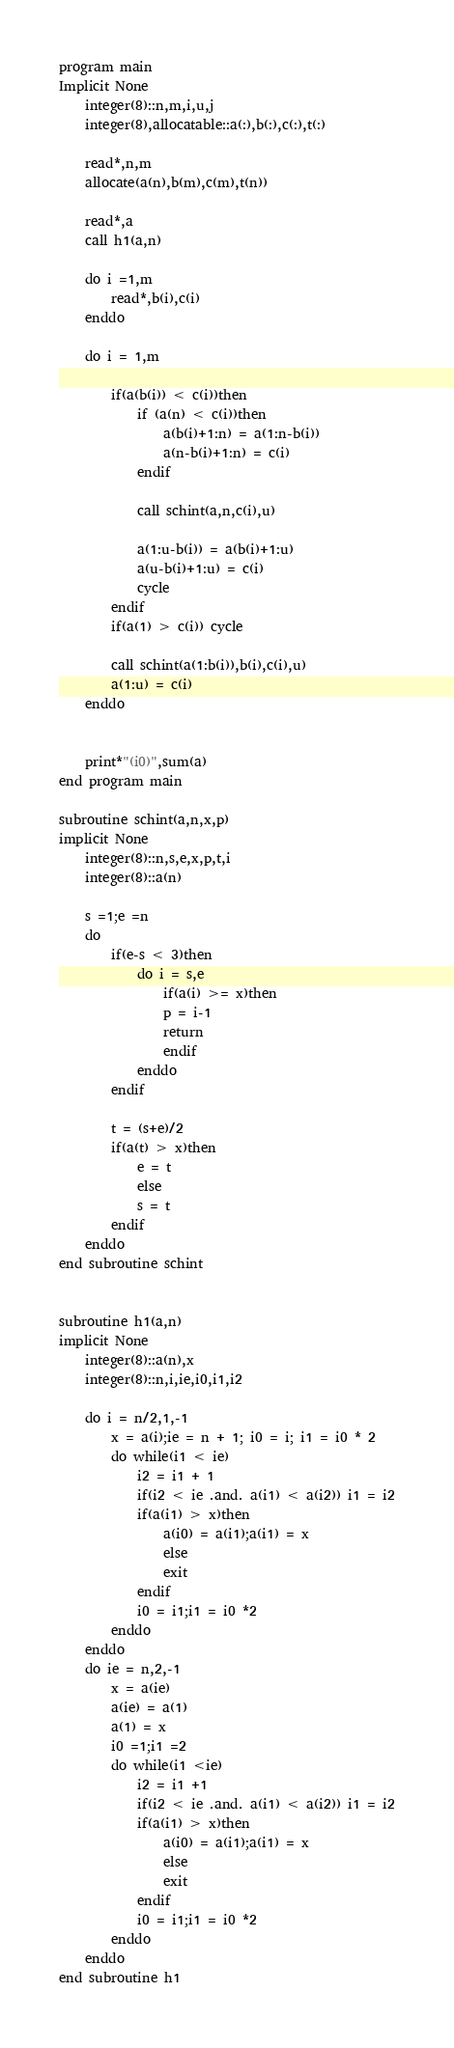<code> <loc_0><loc_0><loc_500><loc_500><_FORTRAN_>program main
Implicit None
	integer(8)::n,m,i,u,j
	integer(8),allocatable::a(:),b(:),c(:),t(:)
	
	read*,n,m
	allocate(a(n),b(m),c(m),t(n))
	
	read*,a
	call h1(a,n)
	
	do i =1,m
		read*,b(i),c(i)
	enddo
	
	do i = 1,m
		
		if(a(b(i)) < c(i))then
			if (a(n) < c(i))then
				a(b(i)+1:n) = a(1:n-b(i))
				a(n-b(i)+1:n) = c(i)
			endif
			
			call schint(a,n,c(i),u)
			
			a(1:u-b(i)) = a(b(i)+1:u)
			a(u-b(i)+1:u) = c(i)
			cycle
		endif 
		if(a(1) > c(i)) cycle
		
		call schint(a(1:b(i)),b(i),c(i),u)
		a(1:u) = c(i)
	enddo
	
	
	print*"(i0)",sum(a)
end program main

subroutine schint(a,n,x,p)
implicit None
	integer(8)::n,s,e,x,p,t,i
	integer(8)::a(n)
	
	s =1;e =n
	do
		if(e-s < 3)then
			do i = s,e
				if(a(i) >= x)then
				p = i-1
				return
				endif
			enddo
		endif
		
		t = (s+e)/2
		if(a(t) > x)then
			e = t
			else
			s = t
		endif
	enddo
end subroutine schint


subroutine h1(a,n)
implicit None
	integer(8)::a(n),x
	integer(8)::n,i,ie,i0,i1,i2
	
	do i = n/2,1,-1
		x = a(i);ie = n + 1; i0 = i; i1 = i0 * 2
		do while(i1 < ie)
			i2 = i1 + 1
			if(i2 < ie .and. a(i1) < a(i2)) i1 = i2
			if(a(i1) > x)then
				a(i0) = a(i1);a(i1) = x
				else
				exit
			endif
			i0 = i1;i1 = i0 *2
		enddo
	enddo
	do ie = n,2,-1
		x = a(ie)
		a(ie) = a(1)
		a(1) = x
		i0 =1;i1 =2
		do while(i1 <ie)
			i2 = i1 +1
			if(i2 < ie .and. a(i1) < a(i2)) i1 = i2
			if(a(i1) > x)then
				a(i0) = a(i1);a(i1) = x
				else
				exit
			endif
			i0 = i1;i1 = i0 *2
		enddo
	enddo
end subroutine h1</code> 